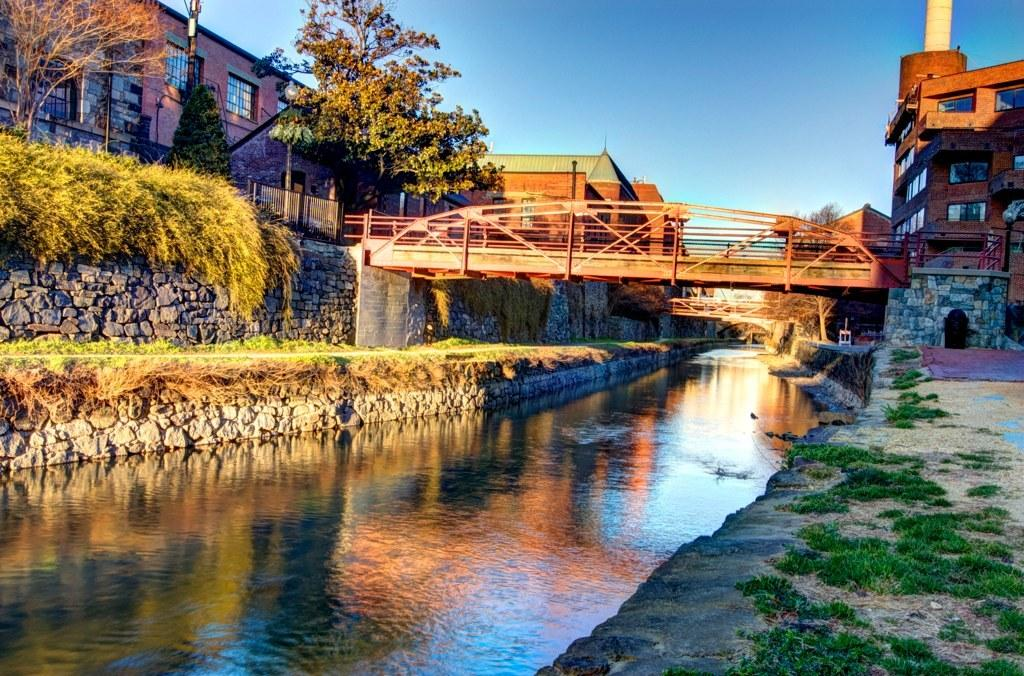What can be seen in the foreground of the image? In the foreground of the image, there is grass, a canal, plants, and a wall. What structures are present in the middle of the image? In the middle of the image, there are buildings, trees, bridges, and other objects. What is visible at the top of the image? The sky is visible at the top of the image. What type of apparel is being sold at the zoo in the image? There is no zoo or apparel being sold present in the image. What is the current temperature in the image? The provided facts do not give any information about the temperature, so it cannot be determined from the image. 